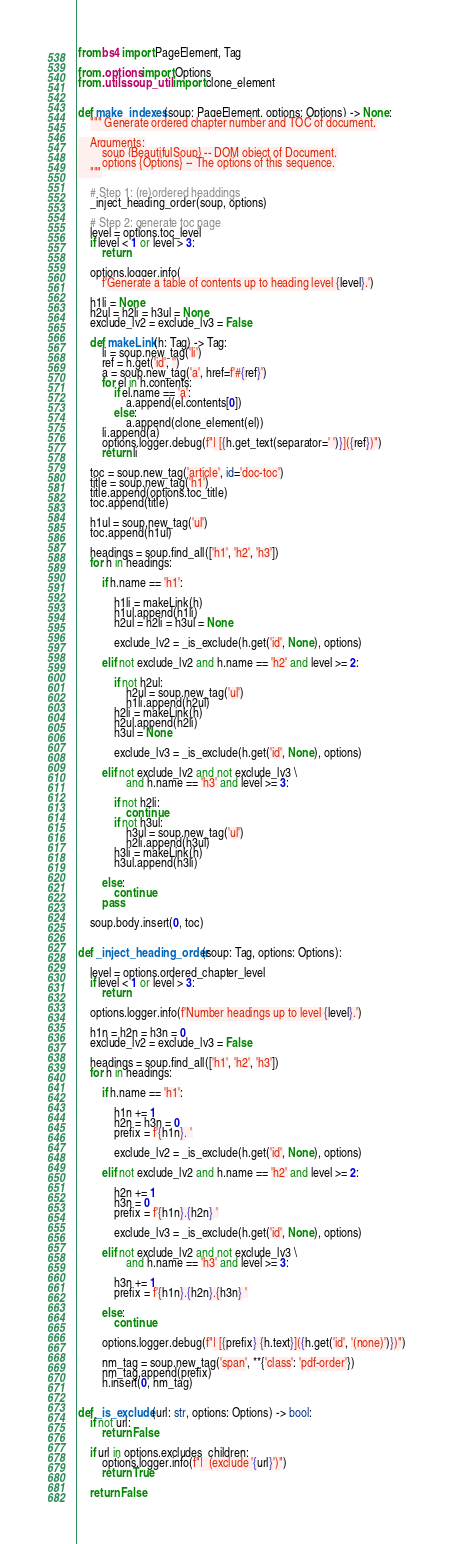<code> <loc_0><loc_0><loc_500><loc_500><_Python_>from bs4 import PageElement, Tag

from .options import Options
from .utils.soup_util import clone_element


def make_indexes(soup: PageElement, options: Options) -> None:
    """ Generate ordered chapter number and TOC of document.

    Arguments:
        soup {BeautifulSoup} -- DOM object of Document.
        options {Options} -- The options of this sequence.
    """

    # Step 1: (re)ordered headdings
    _inject_heading_order(soup, options)

    # Step 2: generate toc page
    level = options.toc_level
    if level < 1 or level > 3:
        return

    options.logger.info(
        f'Generate a table of contents up to heading level {level}.')

    h1li = None
    h2ul = h2li = h3ul = None
    exclude_lv2 = exclude_lv3 = False

    def makeLink(h: Tag) -> Tag:
        li = soup.new_tag('li')
        ref = h.get('id', '')
        a = soup.new_tag('a', href=f'#{ref}')
        for el in h.contents:
            if el.name == 'a':
                a.append(el.contents[0])
            else:
                a.append(clone_element(el))
        li.append(a)
        options.logger.debug(f"| [{h.get_text(separator=' ')}]({ref})")
        return li

    toc = soup.new_tag('article', id='doc-toc')
    title = soup.new_tag('h1')
    title.append(options.toc_title)
    toc.append(title)

    h1ul = soup.new_tag('ul')
    toc.append(h1ul)

    headings = soup.find_all(['h1', 'h2', 'h3'])
    for h in headings:

        if h.name == 'h1':

            h1li = makeLink(h)
            h1ul.append(h1li)
            h2ul = h2li = h3ul = None

            exclude_lv2 = _is_exclude(h.get('id', None), options)

        elif not exclude_lv2 and h.name == 'h2' and level >= 2:

            if not h2ul:
                h2ul = soup.new_tag('ul')
                h1li.append(h2ul)
            h2li = makeLink(h)
            h2ul.append(h2li)
            h3ul = None

            exclude_lv3 = _is_exclude(h.get('id', None), options)

        elif not exclude_lv2 and not exclude_lv3 \
                and h.name == 'h3' and level >= 3:

            if not h2li:
                continue
            if not h3ul:
                h3ul = soup.new_tag('ul')
                h2li.append(h3ul)
            h3li = makeLink(h)
            h3ul.append(h3li)

        else:
            continue
        pass

    soup.body.insert(0, toc)


def _inject_heading_order(soup: Tag, options: Options):

    level = options.ordered_chapter_level
    if level < 1 or level > 3:
        return

    options.logger.info(f'Number headings up to level {level}.')

    h1n = h2n = h3n = 0
    exclude_lv2 = exclude_lv3 = False

    headings = soup.find_all(['h1', 'h2', 'h3'])
    for h in headings:

        if h.name == 'h1':

            h1n += 1
            h2n = h3n = 0
            prefix = f'{h1n}. '

            exclude_lv2 = _is_exclude(h.get('id', None), options)

        elif not exclude_lv2 and h.name == 'h2' and level >= 2:

            h2n += 1
            h3n = 0
            prefix = f'{h1n}.{h2n} '

            exclude_lv3 = _is_exclude(h.get('id', None), options)

        elif not exclude_lv2 and not exclude_lv3 \
                and h.name == 'h3' and level >= 3:

            h3n += 1
            prefix = f'{h1n}.{h2n}.{h3n} '

        else:
            continue

        options.logger.debug(f"| [{prefix} {h.text}]({h.get('id', '(none)')})")

        nm_tag = soup.new_tag('span', **{'class': 'pdf-order'})
        nm_tag.append(prefix)
        h.insert(0, nm_tag)


def _is_exclude(url: str, options: Options) -> bool:
    if not url:
        return False

    if url in options.excludes_children:
        options.logger.info(f"|  (exclude '{url}')")
        return True

    return False
</code> 